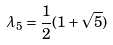<formula> <loc_0><loc_0><loc_500><loc_500>\lambda _ { 5 } = \frac { 1 } { 2 } ( 1 + \sqrt { 5 } )</formula> 